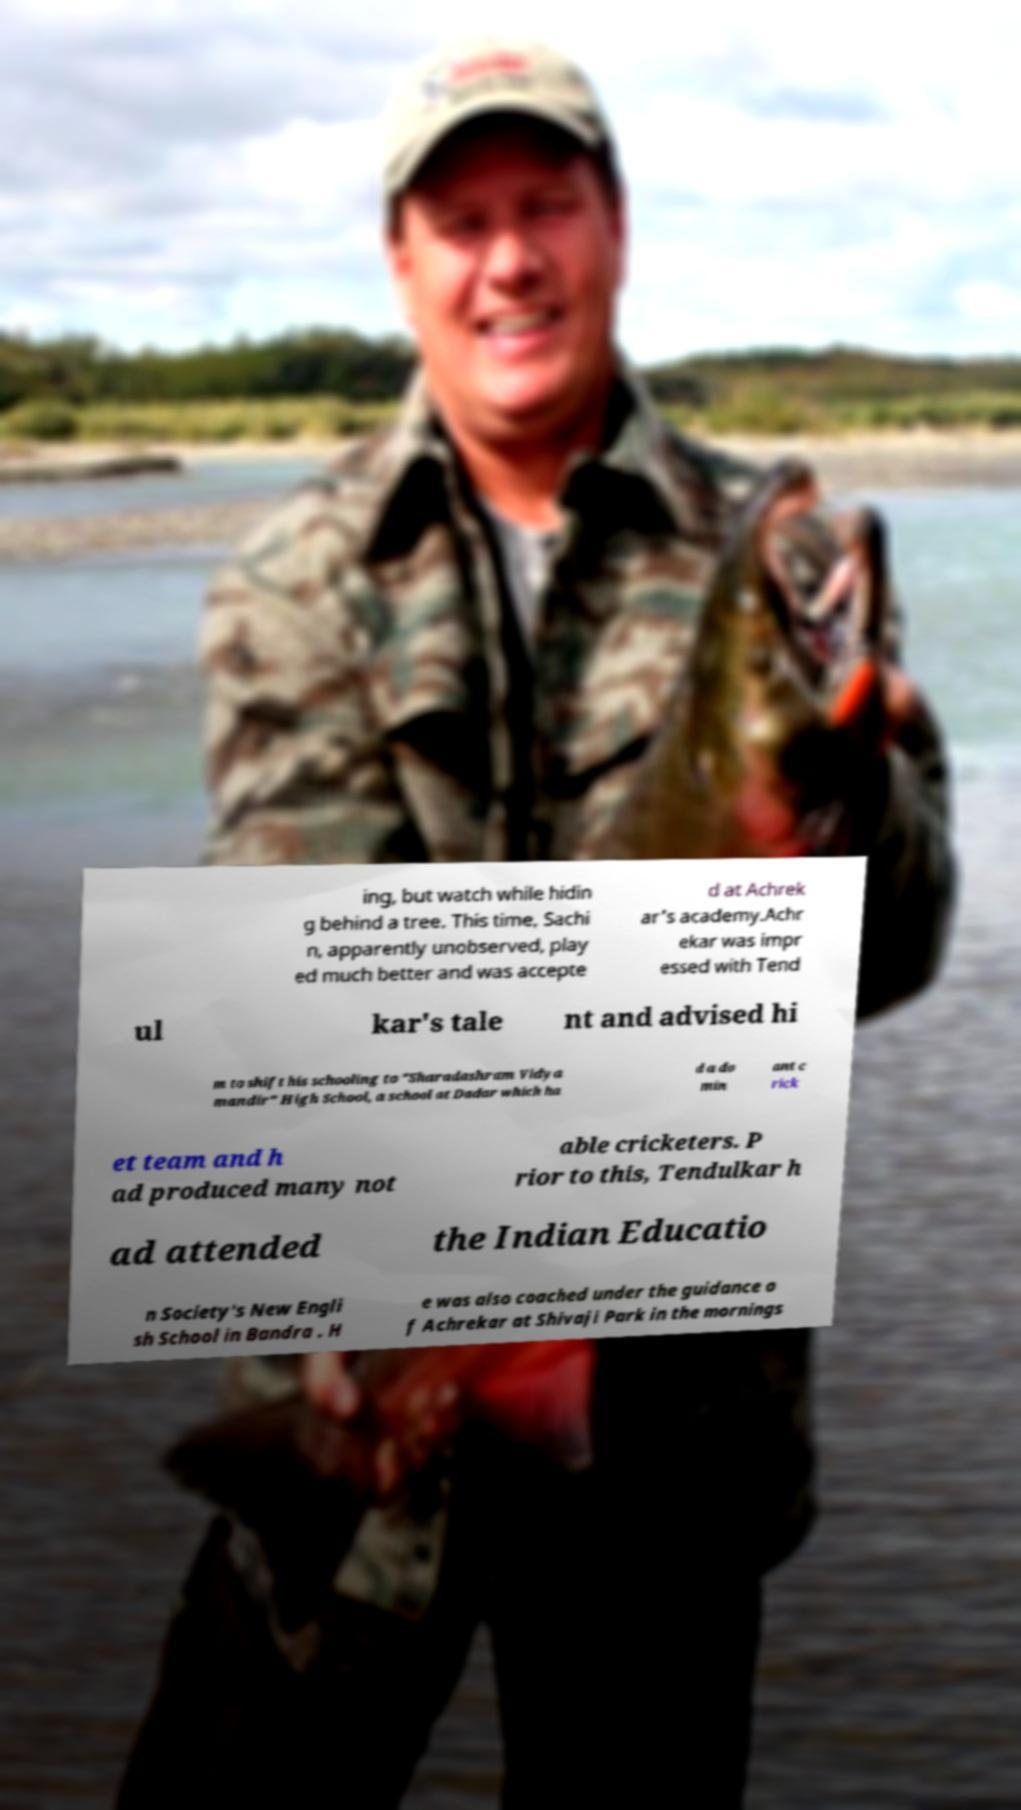Could you assist in decoding the text presented in this image and type it out clearly? ing, but watch while hidin g behind a tree. This time, Sachi n, apparently unobserved, play ed much better and was accepte d at Achrek ar's academy.Achr ekar was impr essed with Tend ul kar's tale nt and advised hi m to shift his schooling to "Sharadashram Vidya mandir" High School, a school at Dadar which ha d a do min ant c rick et team and h ad produced many not able cricketers. P rior to this, Tendulkar h ad attended the Indian Educatio n Society's New Engli sh School in Bandra . H e was also coached under the guidance o f Achrekar at Shivaji Park in the mornings 